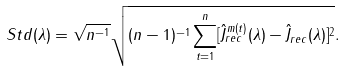<formula> <loc_0><loc_0><loc_500><loc_500>S t d ( \lambda ) = \sqrt { n ^ { - 1 } } \sqrt { ( n - 1 ) ^ { - 1 } \sum _ { t = 1 } ^ { n } [ \hat { J } _ { r e c } ^ { m ( t ) } ( \lambda ) - \hat { J } _ { r e c } ( \lambda ) ] ^ { 2 } } .</formula> 